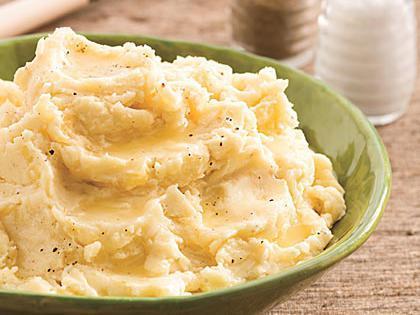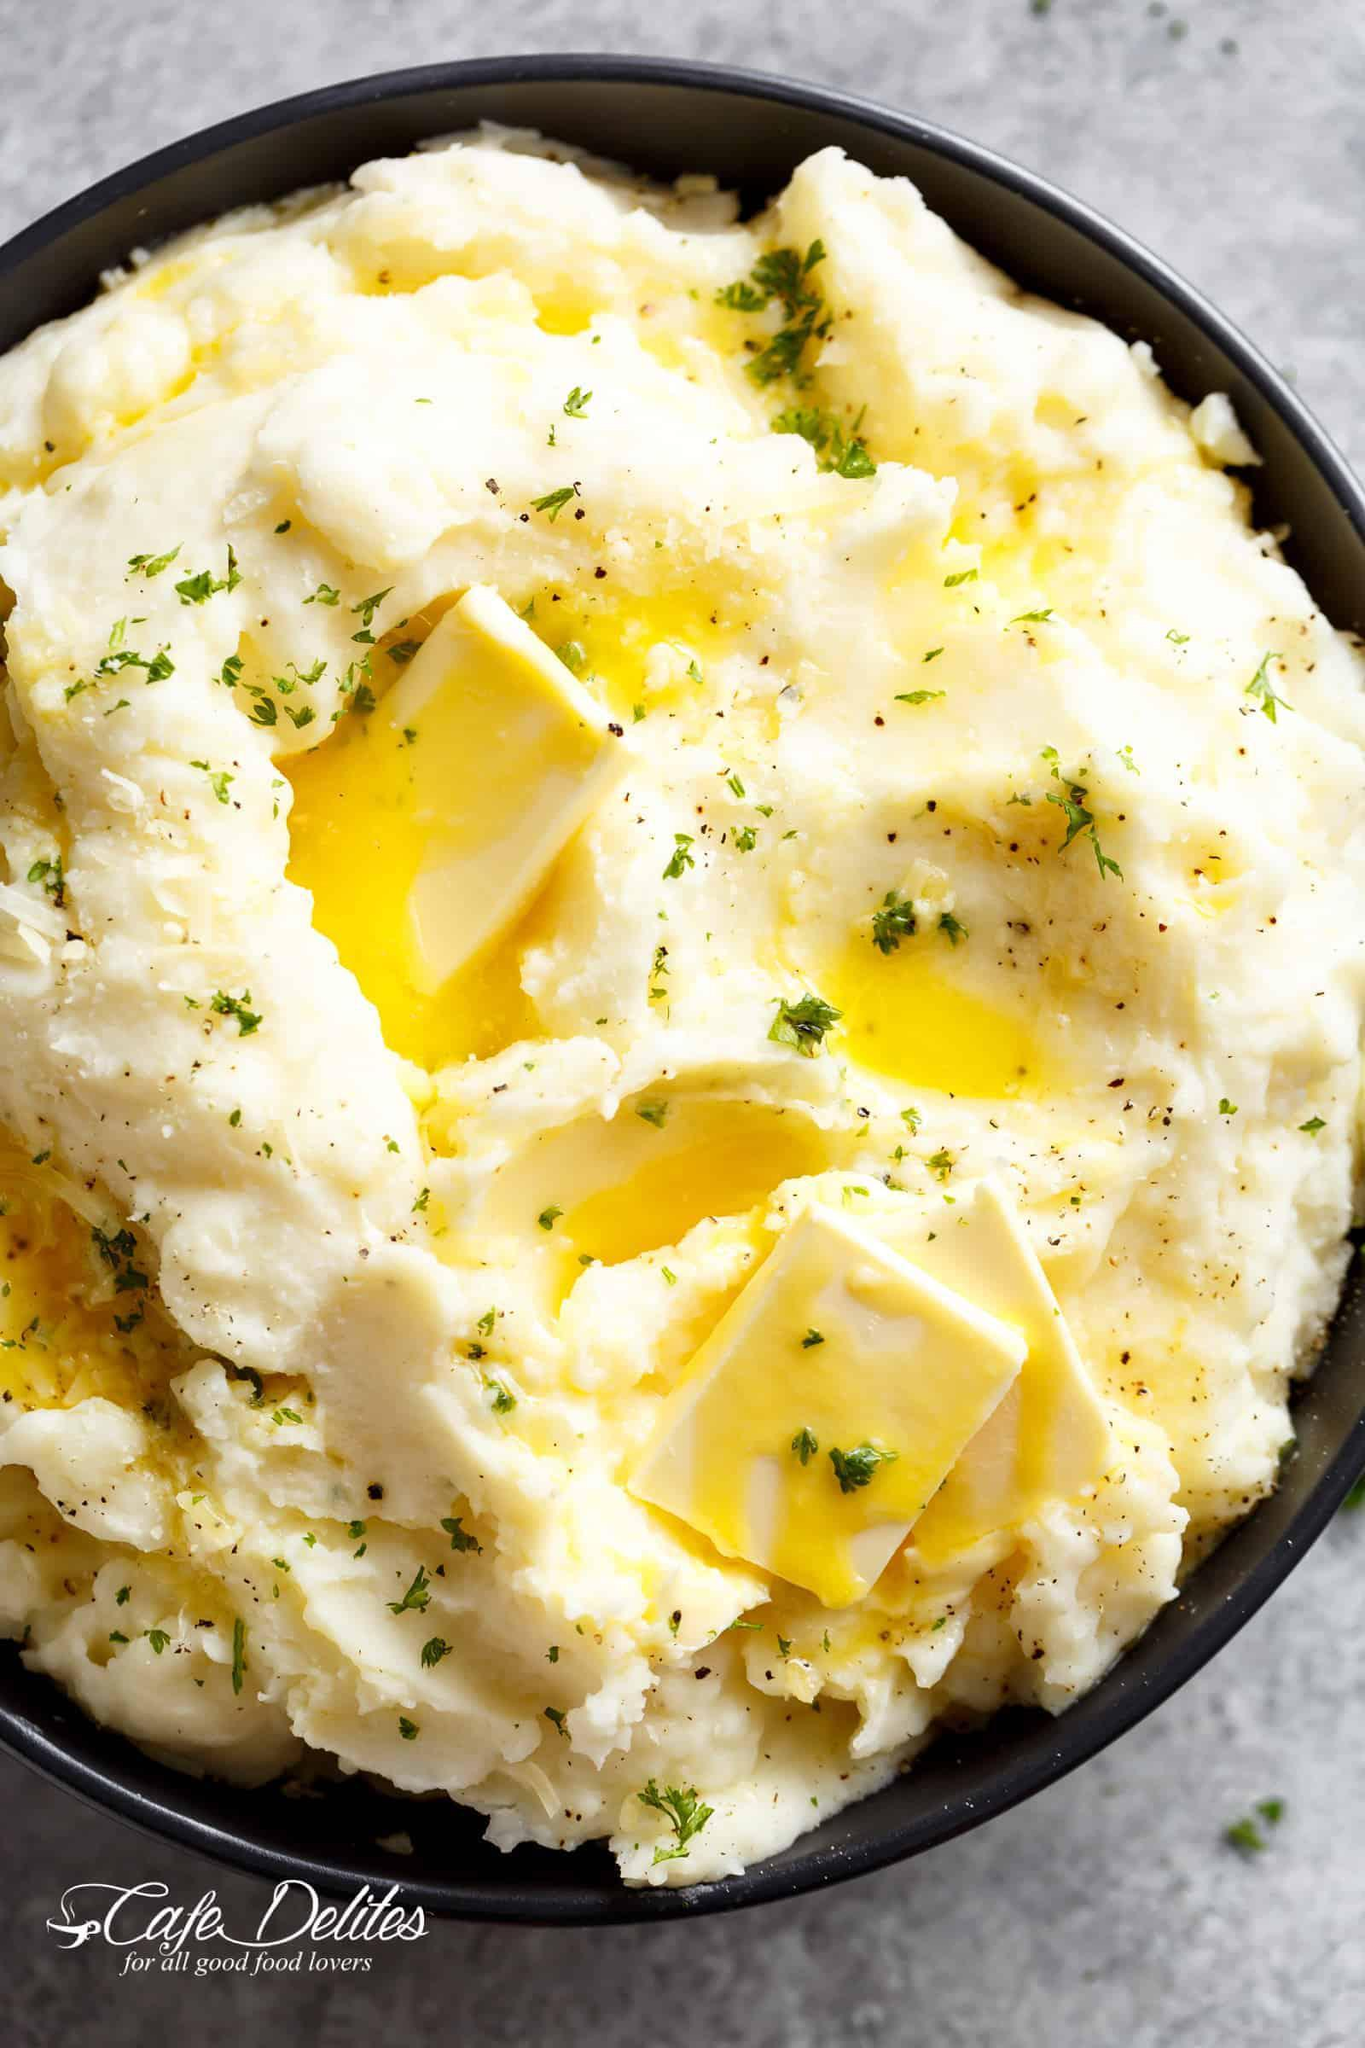The first image is the image on the left, the second image is the image on the right. Analyze the images presented: Is the assertion "The left and right image contains a total of two colored mashed potato bowls." valid? Answer yes or no. Yes. The first image is the image on the left, the second image is the image on the right. For the images shown, is this caption "The right image includes a round brown bowl with mashed potatoes in it and a spoon." true? Answer yes or no. No. 